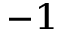Convert formula to latex. <formula><loc_0><loc_0><loc_500><loc_500>^ { - 1 }</formula> 